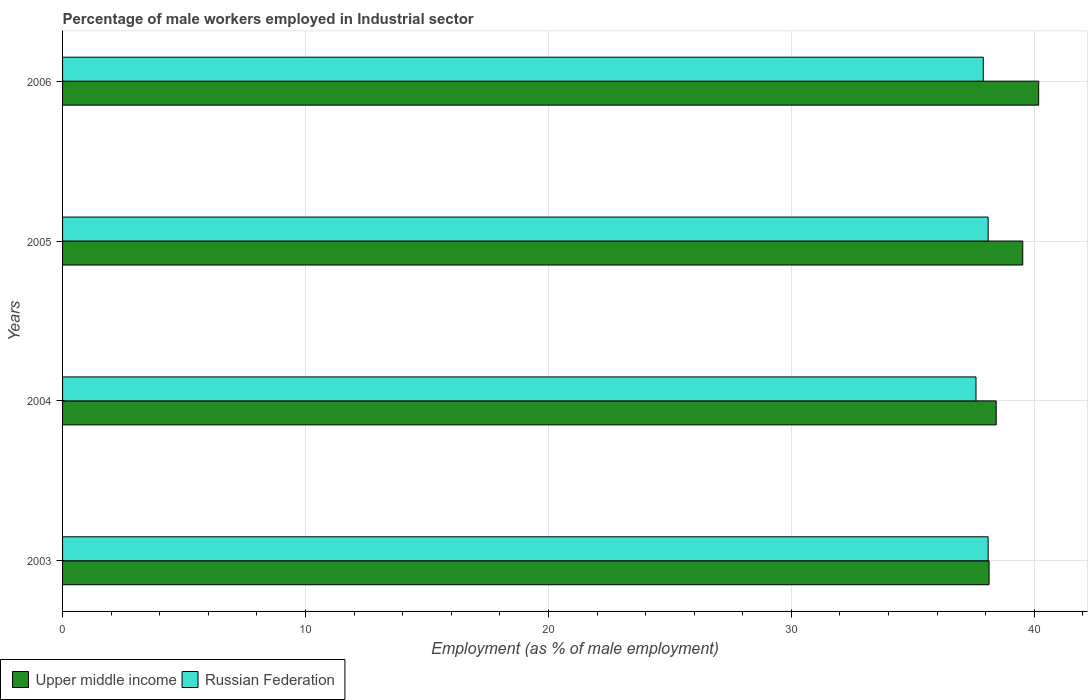How many different coloured bars are there?
Give a very brief answer. 2. How many groups of bars are there?
Offer a very short reply. 4. What is the percentage of male workers employed in Industrial sector in Upper middle income in 2006?
Give a very brief answer. 40.18. Across all years, what is the maximum percentage of male workers employed in Industrial sector in Upper middle income?
Provide a short and direct response. 40.18. Across all years, what is the minimum percentage of male workers employed in Industrial sector in Upper middle income?
Provide a succinct answer. 38.14. In which year was the percentage of male workers employed in Industrial sector in Russian Federation minimum?
Keep it short and to the point. 2004. What is the total percentage of male workers employed in Industrial sector in Upper middle income in the graph?
Give a very brief answer. 156.27. What is the difference between the percentage of male workers employed in Industrial sector in Upper middle income in 2004 and that in 2005?
Ensure brevity in your answer.  -1.09. What is the difference between the percentage of male workers employed in Industrial sector in Russian Federation in 2006 and the percentage of male workers employed in Industrial sector in Upper middle income in 2005?
Your response must be concise. -1.62. What is the average percentage of male workers employed in Industrial sector in Russian Federation per year?
Your answer should be very brief. 37.92. In the year 2006, what is the difference between the percentage of male workers employed in Industrial sector in Russian Federation and percentage of male workers employed in Industrial sector in Upper middle income?
Ensure brevity in your answer.  -2.28. In how many years, is the percentage of male workers employed in Industrial sector in Upper middle income greater than 4 %?
Ensure brevity in your answer.  4. What is the ratio of the percentage of male workers employed in Industrial sector in Upper middle income in 2003 to that in 2006?
Offer a very short reply. 0.95. Is the percentage of male workers employed in Industrial sector in Upper middle income in 2004 less than that in 2005?
Provide a short and direct response. Yes. In how many years, is the percentage of male workers employed in Industrial sector in Upper middle income greater than the average percentage of male workers employed in Industrial sector in Upper middle income taken over all years?
Give a very brief answer. 2. What does the 1st bar from the top in 2006 represents?
Provide a short and direct response. Russian Federation. What does the 1st bar from the bottom in 2006 represents?
Ensure brevity in your answer.  Upper middle income. How many bars are there?
Your answer should be compact. 8. Are all the bars in the graph horizontal?
Keep it short and to the point. Yes. What is the difference between two consecutive major ticks on the X-axis?
Your answer should be compact. 10. Does the graph contain any zero values?
Your response must be concise. No. Where does the legend appear in the graph?
Keep it short and to the point. Bottom left. How many legend labels are there?
Your answer should be compact. 2. How are the legend labels stacked?
Your response must be concise. Horizontal. What is the title of the graph?
Your answer should be compact. Percentage of male workers employed in Industrial sector. Does "United States" appear as one of the legend labels in the graph?
Your answer should be compact. No. What is the label or title of the X-axis?
Offer a terse response. Employment (as % of male employment). What is the label or title of the Y-axis?
Give a very brief answer. Years. What is the Employment (as % of male employment) in Upper middle income in 2003?
Ensure brevity in your answer.  38.14. What is the Employment (as % of male employment) of Russian Federation in 2003?
Give a very brief answer. 38.1. What is the Employment (as % of male employment) in Upper middle income in 2004?
Offer a very short reply. 38.43. What is the Employment (as % of male employment) in Russian Federation in 2004?
Make the answer very short. 37.6. What is the Employment (as % of male employment) of Upper middle income in 2005?
Provide a succinct answer. 39.52. What is the Employment (as % of male employment) of Russian Federation in 2005?
Make the answer very short. 38.1. What is the Employment (as % of male employment) in Upper middle income in 2006?
Provide a short and direct response. 40.18. What is the Employment (as % of male employment) of Russian Federation in 2006?
Your answer should be compact. 37.9. Across all years, what is the maximum Employment (as % of male employment) in Upper middle income?
Offer a very short reply. 40.18. Across all years, what is the maximum Employment (as % of male employment) in Russian Federation?
Your answer should be compact. 38.1. Across all years, what is the minimum Employment (as % of male employment) of Upper middle income?
Give a very brief answer. 38.14. Across all years, what is the minimum Employment (as % of male employment) in Russian Federation?
Your answer should be compact. 37.6. What is the total Employment (as % of male employment) in Upper middle income in the graph?
Make the answer very short. 156.27. What is the total Employment (as % of male employment) in Russian Federation in the graph?
Make the answer very short. 151.7. What is the difference between the Employment (as % of male employment) of Upper middle income in 2003 and that in 2004?
Your response must be concise. -0.29. What is the difference between the Employment (as % of male employment) in Russian Federation in 2003 and that in 2004?
Provide a short and direct response. 0.5. What is the difference between the Employment (as % of male employment) in Upper middle income in 2003 and that in 2005?
Keep it short and to the point. -1.39. What is the difference between the Employment (as % of male employment) in Upper middle income in 2003 and that in 2006?
Offer a terse response. -2.04. What is the difference between the Employment (as % of male employment) of Upper middle income in 2004 and that in 2005?
Make the answer very short. -1.09. What is the difference between the Employment (as % of male employment) in Russian Federation in 2004 and that in 2005?
Keep it short and to the point. -0.5. What is the difference between the Employment (as % of male employment) of Upper middle income in 2004 and that in 2006?
Provide a succinct answer. -1.75. What is the difference between the Employment (as % of male employment) in Upper middle income in 2005 and that in 2006?
Keep it short and to the point. -0.66. What is the difference between the Employment (as % of male employment) of Upper middle income in 2003 and the Employment (as % of male employment) of Russian Federation in 2004?
Your answer should be compact. 0.54. What is the difference between the Employment (as % of male employment) in Upper middle income in 2003 and the Employment (as % of male employment) in Russian Federation in 2005?
Offer a very short reply. 0.04. What is the difference between the Employment (as % of male employment) of Upper middle income in 2003 and the Employment (as % of male employment) of Russian Federation in 2006?
Your response must be concise. 0.24. What is the difference between the Employment (as % of male employment) of Upper middle income in 2004 and the Employment (as % of male employment) of Russian Federation in 2005?
Provide a short and direct response. 0.33. What is the difference between the Employment (as % of male employment) in Upper middle income in 2004 and the Employment (as % of male employment) in Russian Federation in 2006?
Provide a short and direct response. 0.53. What is the difference between the Employment (as % of male employment) in Upper middle income in 2005 and the Employment (as % of male employment) in Russian Federation in 2006?
Keep it short and to the point. 1.62. What is the average Employment (as % of male employment) in Upper middle income per year?
Keep it short and to the point. 39.07. What is the average Employment (as % of male employment) of Russian Federation per year?
Your answer should be very brief. 37.92. In the year 2003, what is the difference between the Employment (as % of male employment) in Upper middle income and Employment (as % of male employment) in Russian Federation?
Your answer should be compact. 0.04. In the year 2004, what is the difference between the Employment (as % of male employment) in Upper middle income and Employment (as % of male employment) in Russian Federation?
Ensure brevity in your answer.  0.83. In the year 2005, what is the difference between the Employment (as % of male employment) in Upper middle income and Employment (as % of male employment) in Russian Federation?
Your response must be concise. 1.42. In the year 2006, what is the difference between the Employment (as % of male employment) in Upper middle income and Employment (as % of male employment) in Russian Federation?
Your response must be concise. 2.28. What is the ratio of the Employment (as % of male employment) of Upper middle income in 2003 to that in 2004?
Make the answer very short. 0.99. What is the ratio of the Employment (as % of male employment) in Russian Federation in 2003 to that in 2004?
Your response must be concise. 1.01. What is the ratio of the Employment (as % of male employment) of Upper middle income in 2003 to that in 2005?
Ensure brevity in your answer.  0.96. What is the ratio of the Employment (as % of male employment) in Russian Federation in 2003 to that in 2005?
Your response must be concise. 1. What is the ratio of the Employment (as % of male employment) in Upper middle income in 2003 to that in 2006?
Your answer should be very brief. 0.95. What is the ratio of the Employment (as % of male employment) of Upper middle income in 2004 to that in 2005?
Offer a terse response. 0.97. What is the ratio of the Employment (as % of male employment) of Russian Federation in 2004 to that in 2005?
Your answer should be compact. 0.99. What is the ratio of the Employment (as % of male employment) in Upper middle income in 2004 to that in 2006?
Give a very brief answer. 0.96. What is the ratio of the Employment (as % of male employment) in Russian Federation in 2004 to that in 2006?
Keep it short and to the point. 0.99. What is the ratio of the Employment (as % of male employment) of Upper middle income in 2005 to that in 2006?
Offer a very short reply. 0.98. What is the ratio of the Employment (as % of male employment) of Russian Federation in 2005 to that in 2006?
Provide a short and direct response. 1.01. What is the difference between the highest and the second highest Employment (as % of male employment) of Upper middle income?
Offer a terse response. 0.66. What is the difference between the highest and the second highest Employment (as % of male employment) in Russian Federation?
Provide a succinct answer. 0. What is the difference between the highest and the lowest Employment (as % of male employment) of Upper middle income?
Give a very brief answer. 2.04. What is the difference between the highest and the lowest Employment (as % of male employment) in Russian Federation?
Your answer should be very brief. 0.5. 